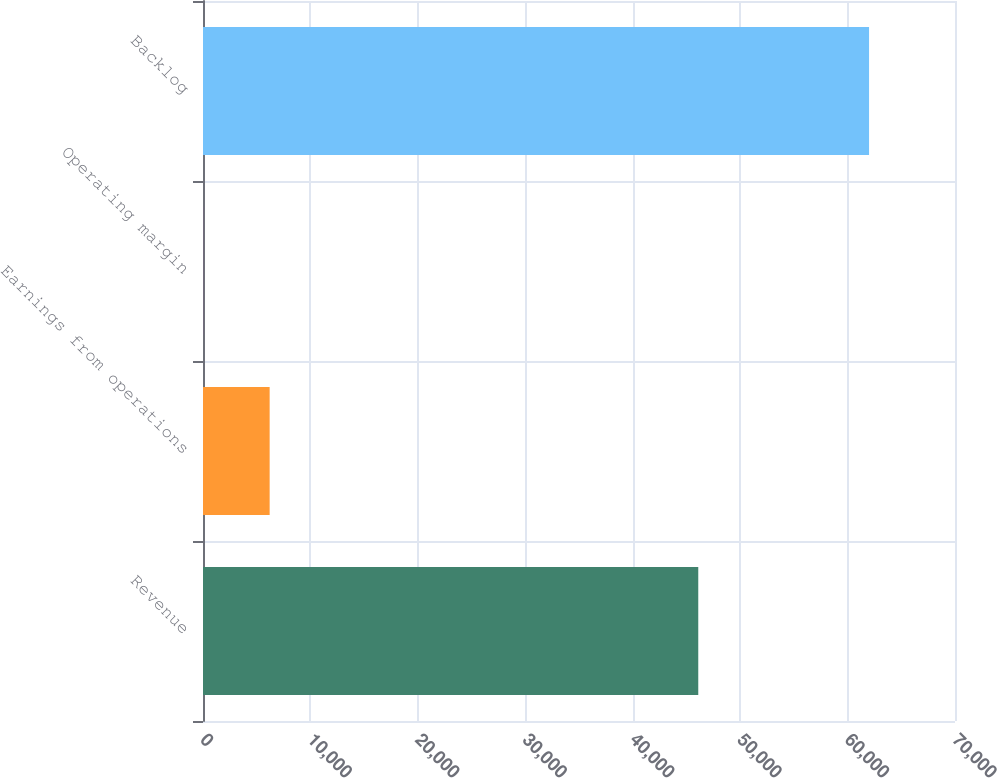<chart> <loc_0><loc_0><loc_500><loc_500><bar_chart><fcel>Revenue<fcel>Earnings from operations<fcel>Operating margin<fcel>Backlog<nl><fcel>46102<fcel>6204.05<fcel>4.5<fcel>62000<nl></chart> 